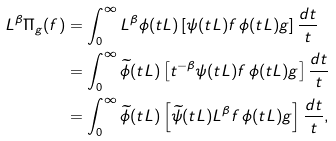Convert formula to latex. <formula><loc_0><loc_0><loc_500><loc_500>L ^ { \beta } \Pi _ { g } ( f ) & = \int _ { 0 } ^ { \infty } L ^ { \beta } \phi ( t L ) \left [ \psi ( t L ) f \, \phi ( t L ) g \right ] \frac { d t } { t } \\ & = \int _ { 0 } ^ { \infty } \widetilde { \phi } ( t L ) \left [ t ^ { - \beta } \psi ( t L ) f \, \phi ( t L ) g \right ] \frac { d t } { t } \\ & = \int _ { 0 } ^ { \infty } \widetilde { \phi } ( t L ) \left [ \widetilde { \psi } ( t L ) L ^ { \beta } f \, \phi ( t L ) g \right ] \frac { d t } { t } ,</formula> 